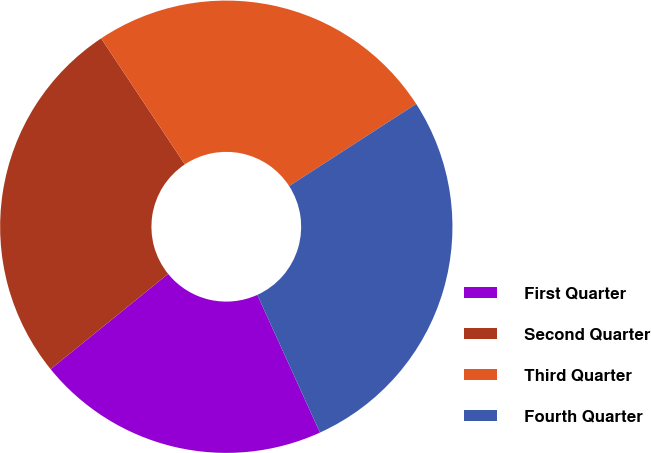Convert chart. <chart><loc_0><loc_0><loc_500><loc_500><pie_chart><fcel>First Quarter<fcel>Second Quarter<fcel>Third Quarter<fcel>Fourth Quarter<nl><fcel>20.96%<fcel>26.51%<fcel>25.2%<fcel>27.34%<nl></chart> 